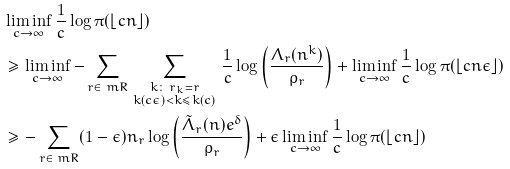Convert formula to latex. <formula><loc_0><loc_0><loc_500><loc_500>& \liminf _ { c \rightarrow \infty } \frac { 1 } { c } \log \pi ( \lfloor c n \rfloor ) \\ & \geq \liminf _ { c \rightarrow \infty } - \sum _ { r \in \ m R } \, \sum _ { \substack { k \colon \, r _ { k } = r \\ k ( c \epsilon ) < k \leq k ( c ) } } \, \frac { 1 } { c } \log \left ( \frac { \Lambda _ { r } ( n ^ { k } ) } { \rho _ { r } } \right ) + \liminf _ { c \rightarrow \infty } \frac { 1 } { c } \log \pi ( \lfloor c n \epsilon \rfloor ) \\ & \geq - \sum _ { r \in \ m R } ( 1 - \epsilon ) n _ { r } \log \left ( \frac { \tilde { \Lambda } _ { r } ( n ) e ^ { \delta } } { \rho _ { r } } \right ) + \epsilon \liminf _ { c \rightarrow \infty } \frac { 1 } { c } \log \pi ( \lfloor c n \rfloor )</formula> 